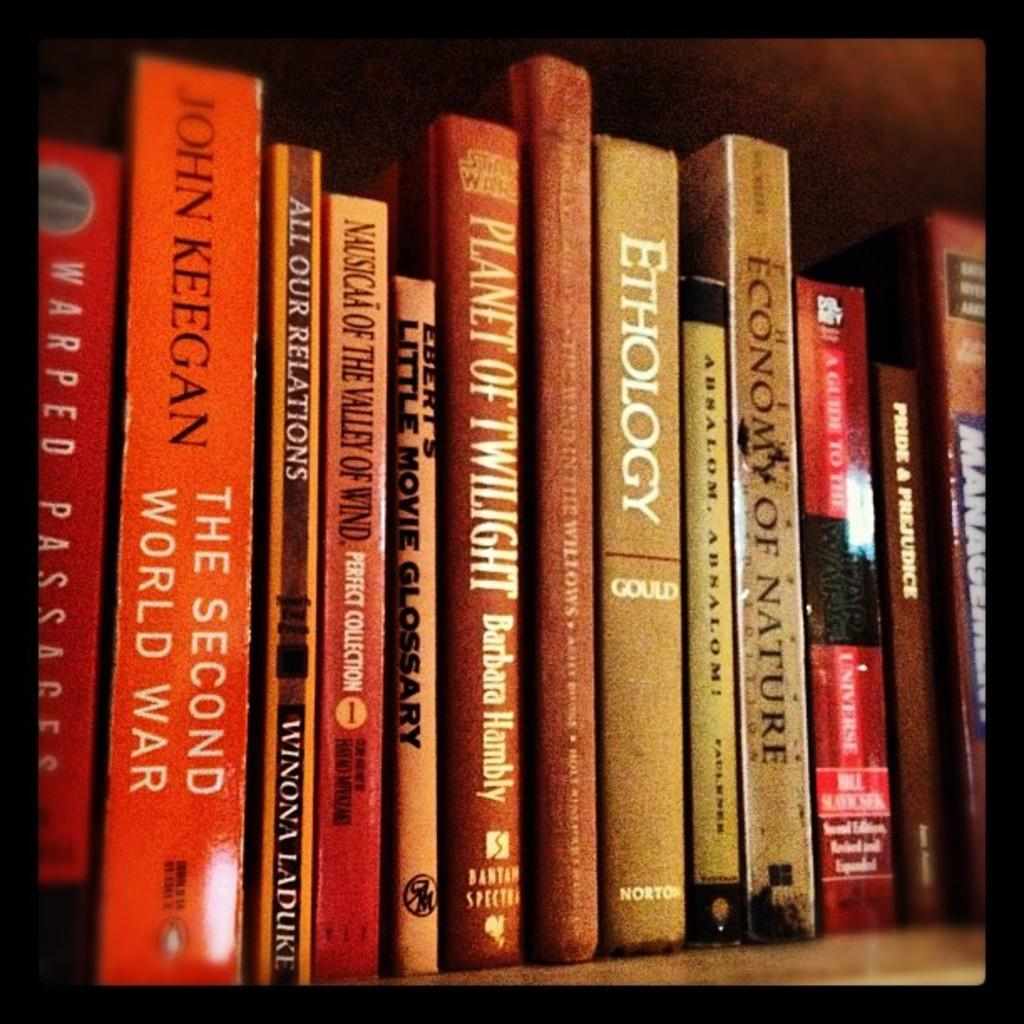<image>
Summarize the visual content of the image. A group of books on a shelf including Ethology, Planet of Twilight and The Second World War. 